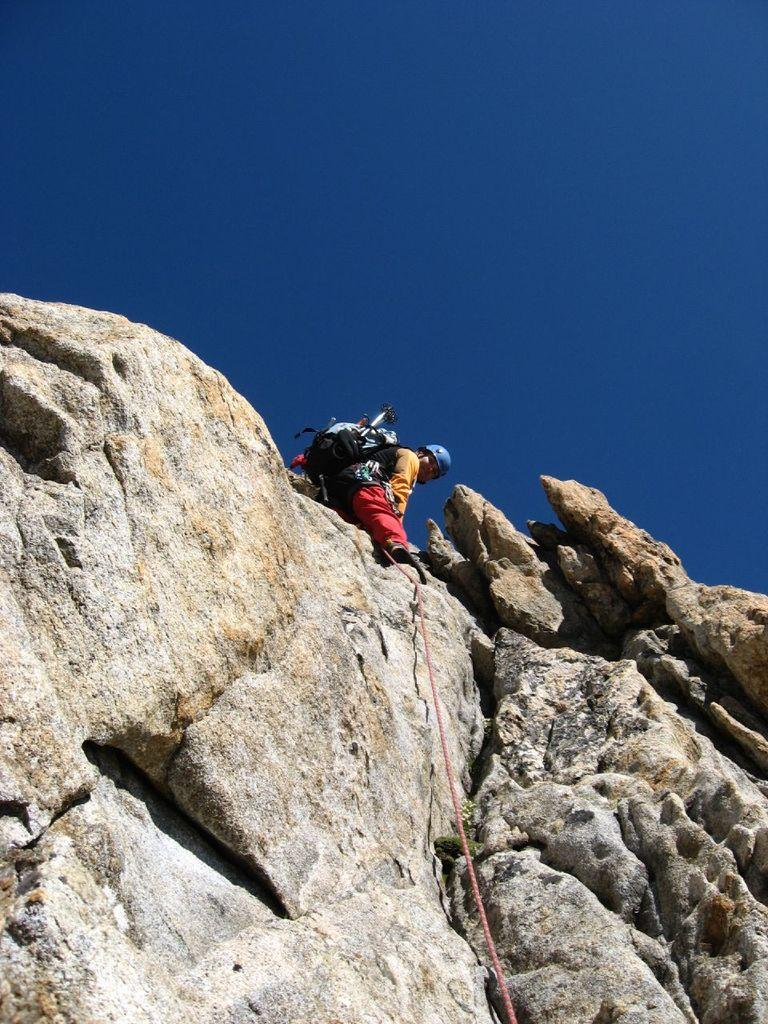What type of natural formation can be seen in the image? There are rocks in the image. What is the person in the image doing? The person is standing on the rocks. What is the person carrying on their back? The person is wearing a backpack. What other object is present in the image? There is a rope in the image. What can be seen in the background of the image? The sky is visible in the background of the image, and it is clear. What type of acoustics can be heard from the rocks in the image? There is no information about the acoustics in the image, as it only shows rocks, a person, a backpack, a rope, and a clear sky in the background. --- Facts: 1. There is a car in the image. 2. The car is parked on the street. 3. There are trees on both sides of the street. 4. The sky is visible in the background of the image. 5. The car has a red color. Absurd Topics: parrot, dance, ocean Conversation: What type of vehicle is in the image? There is a car in the image. Where is the car located? The car is parked on the street. What type of vegetation can be seen on both sides of the street? There are trees on both sides of the street. What can be seen in the background of the image? The sky is visible in the background of the image. What is the color of the car? The car has a red color. Reasoning: Let's think step by step in order to produce the conversation. We start by identifying the main subject in the image, which is the car. Then, we expand the conversation to include the car's location, the trees on both sides of the street, the sky in the background, and the car's color. Each question is designed to elicit a specific detail about the image that is known from the provided facts. Absurd Question/Answer: Can you see a parrot dancing near the ocean in the image? There is no parrot, dancing, or ocean present in the image; it only shows a red car parked on the street with trees on both sides and a visible sky in the background. 